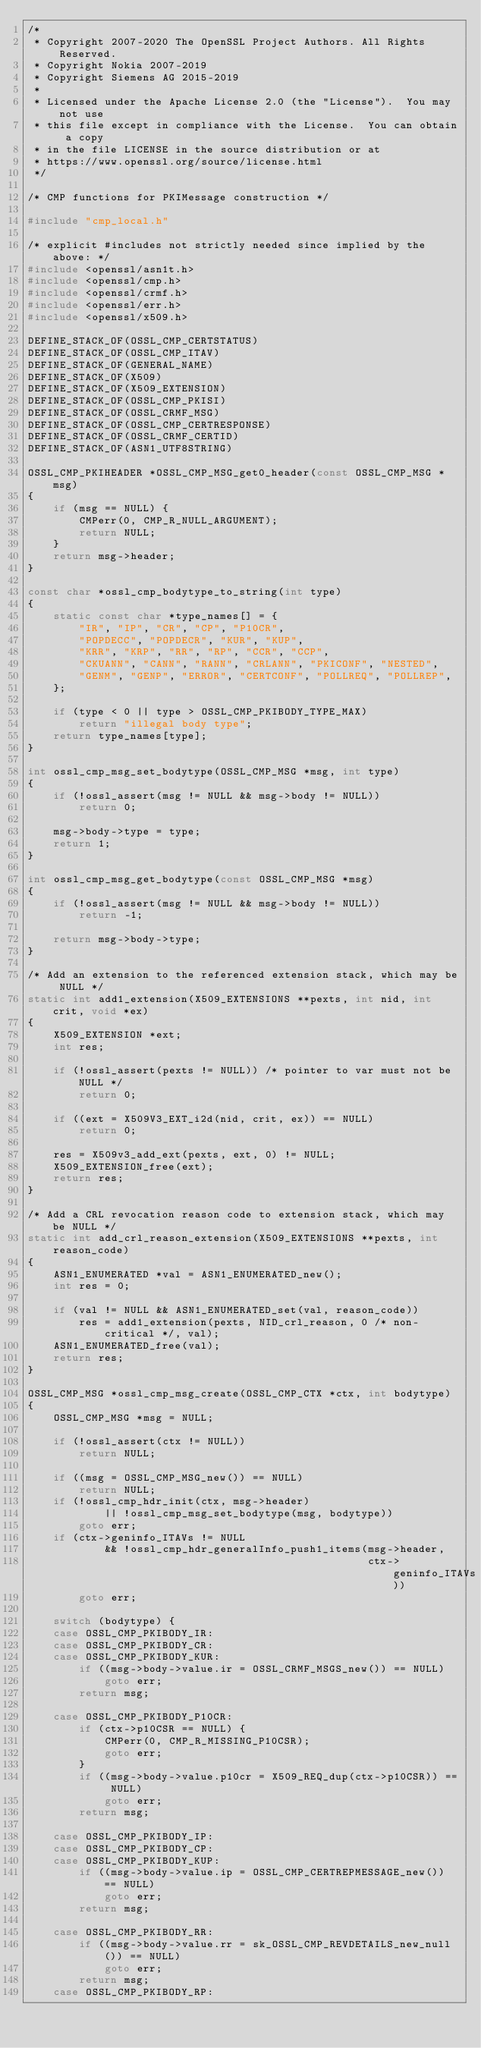<code> <loc_0><loc_0><loc_500><loc_500><_C_>/*
 * Copyright 2007-2020 The OpenSSL Project Authors. All Rights Reserved.
 * Copyright Nokia 2007-2019
 * Copyright Siemens AG 2015-2019
 *
 * Licensed under the Apache License 2.0 (the "License").  You may not use
 * this file except in compliance with the License.  You can obtain a copy
 * in the file LICENSE in the source distribution or at
 * https://www.openssl.org/source/license.html
 */

/* CMP functions for PKIMessage construction */

#include "cmp_local.h"

/* explicit #includes not strictly needed since implied by the above: */
#include <openssl/asn1t.h>
#include <openssl/cmp.h>
#include <openssl/crmf.h>
#include <openssl/err.h>
#include <openssl/x509.h>

DEFINE_STACK_OF(OSSL_CMP_CERTSTATUS)
DEFINE_STACK_OF(OSSL_CMP_ITAV)
DEFINE_STACK_OF(GENERAL_NAME)
DEFINE_STACK_OF(X509)
DEFINE_STACK_OF(X509_EXTENSION)
DEFINE_STACK_OF(OSSL_CMP_PKISI)
DEFINE_STACK_OF(OSSL_CRMF_MSG)
DEFINE_STACK_OF(OSSL_CMP_CERTRESPONSE)
DEFINE_STACK_OF(OSSL_CRMF_CERTID)
DEFINE_STACK_OF(ASN1_UTF8STRING)

OSSL_CMP_PKIHEADER *OSSL_CMP_MSG_get0_header(const OSSL_CMP_MSG *msg)
{
    if (msg == NULL) {
        CMPerr(0, CMP_R_NULL_ARGUMENT);
        return NULL;
    }
    return msg->header;
}

const char *ossl_cmp_bodytype_to_string(int type)
{
    static const char *type_names[] = {
        "IR", "IP", "CR", "CP", "P10CR",
        "POPDECC", "POPDECR", "KUR", "KUP",
        "KRR", "KRP", "RR", "RP", "CCR", "CCP",
        "CKUANN", "CANN", "RANN", "CRLANN", "PKICONF", "NESTED",
        "GENM", "GENP", "ERROR", "CERTCONF", "POLLREQ", "POLLREP",
    };

    if (type < 0 || type > OSSL_CMP_PKIBODY_TYPE_MAX)
        return "illegal body type";
    return type_names[type];
}

int ossl_cmp_msg_set_bodytype(OSSL_CMP_MSG *msg, int type)
{
    if (!ossl_assert(msg != NULL && msg->body != NULL))
        return 0;

    msg->body->type = type;
    return 1;
}

int ossl_cmp_msg_get_bodytype(const OSSL_CMP_MSG *msg)
{
    if (!ossl_assert(msg != NULL && msg->body != NULL))
        return -1;

    return msg->body->type;
}

/* Add an extension to the referenced extension stack, which may be NULL */
static int add1_extension(X509_EXTENSIONS **pexts, int nid, int crit, void *ex)
{
    X509_EXTENSION *ext;
    int res;

    if (!ossl_assert(pexts != NULL)) /* pointer to var must not be NULL */
        return 0;

    if ((ext = X509V3_EXT_i2d(nid, crit, ex)) == NULL)
        return 0;

    res = X509v3_add_ext(pexts, ext, 0) != NULL;
    X509_EXTENSION_free(ext);
    return res;
}

/* Add a CRL revocation reason code to extension stack, which may be NULL */
static int add_crl_reason_extension(X509_EXTENSIONS **pexts, int reason_code)
{
    ASN1_ENUMERATED *val = ASN1_ENUMERATED_new();
    int res = 0;

    if (val != NULL && ASN1_ENUMERATED_set(val, reason_code))
        res = add1_extension(pexts, NID_crl_reason, 0 /* non-critical */, val);
    ASN1_ENUMERATED_free(val);
    return res;
}

OSSL_CMP_MSG *ossl_cmp_msg_create(OSSL_CMP_CTX *ctx, int bodytype)
{
    OSSL_CMP_MSG *msg = NULL;

    if (!ossl_assert(ctx != NULL))
        return NULL;

    if ((msg = OSSL_CMP_MSG_new()) == NULL)
        return NULL;
    if (!ossl_cmp_hdr_init(ctx, msg->header)
            || !ossl_cmp_msg_set_bodytype(msg, bodytype))
        goto err;
    if (ctx->geninfo_ITAVs != NULL
            && !ossl_cmp_hdr_generalInfo_push1_items(msg->header,
                                                     ctx->geninfo_ITAVs))
        goto err;

    switch (bodytype) {
    case OSSL_CMP_PKIBODY_IR:
    case OSSL_CMP_PKIBODY_CR:
    case OSSL_CMP_PKIBODY_KUR:
        if ((msg->body->value.ir = OSSL_CRMF_MSGS_new()) == NULL)
            goto err;
        return msg;

    case OSSL_CMP_PKIBODY_P10CR:
        if (ctx->p10CSR == NULL) {
            CMPerr(0, CMP_R_MISSING_P10CSR);
            goto err;
        }
        if ((msg->body->value.p10cr = X509_REQ_dup(ctx->p10CSR)) == NULL)
            goto err;
        return msg;

    case OSSL_CMP_PKIBODY_IP:
    case OSSL_CMP_PKIBODY_CP:
    case OSSL_CMP_PKIBODY_KUP:
        if ((msg->body->value.ip = OSSL_CMP_CERTREPMESSAGE_new()) == NULL)
            goto err;
        return msg;

    case OSSL_CMP_PKIBODY_RR:
        if ((msg->body->value.rr = sk_OSSL_CMP_REVDETAILS_new_null()) == NULL)
            goto err;
        return msg;
    case OSSL_CMP_PKIBODY_RP:</code> 